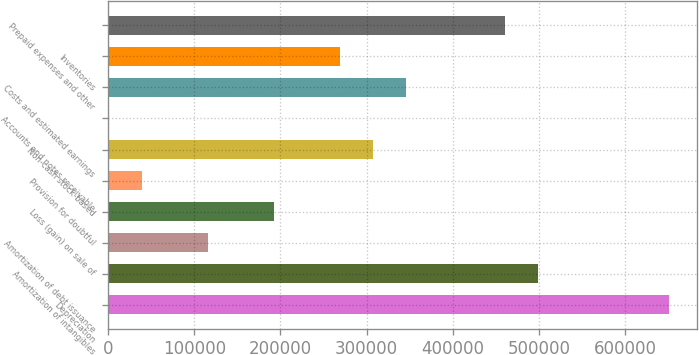<chart> <loc_0><loc_0><loc_500><loc_500><bar_chart><fcel>Depreciation<fcel>Amortization of intangibles<fcel>Amortization of debt issuance<fcel>Loss (gain) on sale of<fcel>Provision for doubtful<fcel>Non-cash stock-based<fcel>Accounts and notes receivable<fcel>Costs and estimated earnings<fcel>Inventories<fcel>Prepaid expenses and other<nl><fcel>651542<fcel>498482<fcel>115832<fcel>192362<fcel>39302<fcel>307157<fcel>1037<fcel>345422<fcel>268892<fcel>460217<nl></chart> 